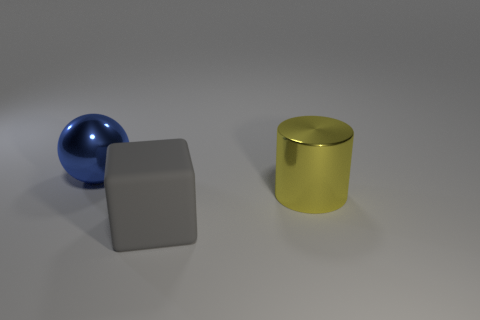Add 2 big yellow metallic cylinders. How many objects exist? 5 Subtract all spheres. How many objects are left? 2 Add 3 large green matte cubes. How many large green matte cubes exist? 3 Subtract 1 blue balls. How many objects are left? 2 Subtract all big shiny spheres. Subtract all gray blocks. How many objects are left? 1 Add 3 yellow objects. How many yellow objects are left? 4 